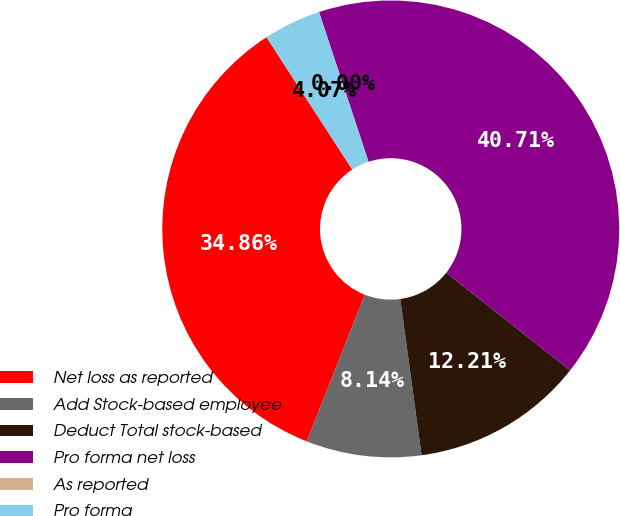Convert chart. <chart><loc_0><loc_0><loc_500><loc_500><pie_chart><fcel>Net loss as reported<fcel>Add Stock-based employee<fcel>Deduct Total stock-based<fcel>Pro forma net loss<fcel>As reported<fcel>Pro forma<nl><fcel>34.86%<fcel>8.14%<fcel>12.21%<fcel>40.71%<fcel>0.0%<fcel>4.07%<nl></chart> 